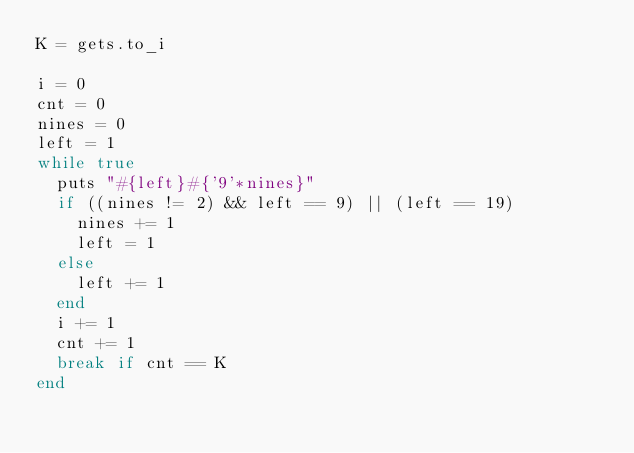Convert code to text. <code><loc_0><loc_0><loc_500><loc_500><_Ruby_>K = gets.to_i

i = 0
cnt = 0
nines = 0
left = 1
while true
  puts "#{left}#{'9'*nines}"
  if ((nines != 2) && left == 9) || (left == 19)
    nines += 1
    left = 1
  else
    left += 1
  end
  i += 1
  cnt += 1
  break if cnt == K
end
</code> 